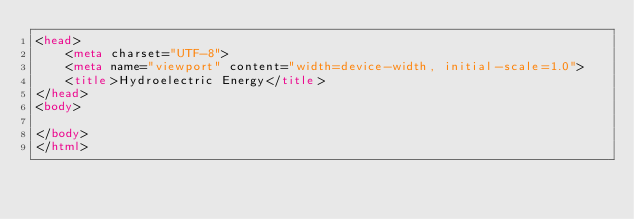<code> <loc_0><loc_0><loc_500><loc_500><_HTML_><head>
    <meta charset="UTF-8">
    <meta name="viewport" content="width=device-width, initial-scale=1.0">
    <title>Hydroelectric Energy</title>
</head>
<body>
    
</body>
</html></code> 